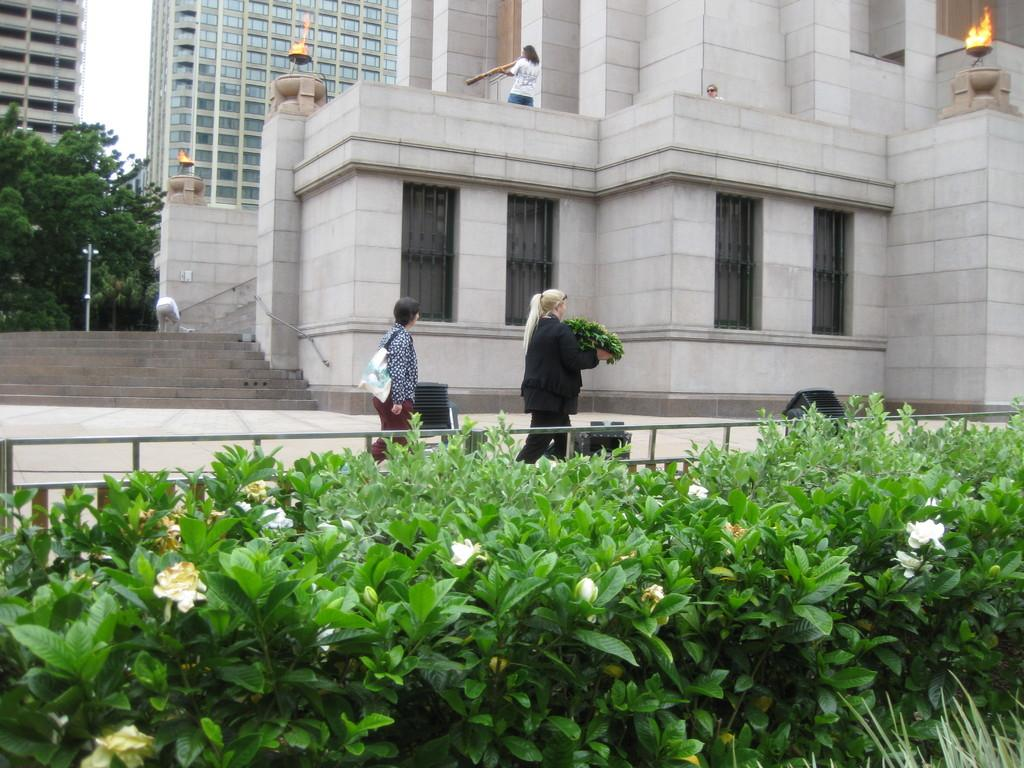What types of living organisms can be seen in the image? Plants and flowers are visible in the image. What material is used for the rods in the image? Metal rods are present in the image. Can you describe the people in the image? There is a group of people in the image. What can be seen in the background of the image? Buildings, trees, and a pole are visible in the background of the image. What is the source of light in the image? Fire is visible in the image. What type of board game is being played by the mom in the image? There is no board game or mom present in the image. Can you tell me the name of the map that the people are using in the image? There is no map present in the image. 